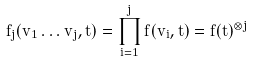Convert formula to latex. <formula><loc_0><loc_0><loc_500><loc_500>f _ { j } ( v _ { 1 } \dots v _ { j } , t ) = \prod _ { i = 1 } ^ { j } f ( v _ { i } , t ) = f ( t ) ^ { \otimes j }</formula> 